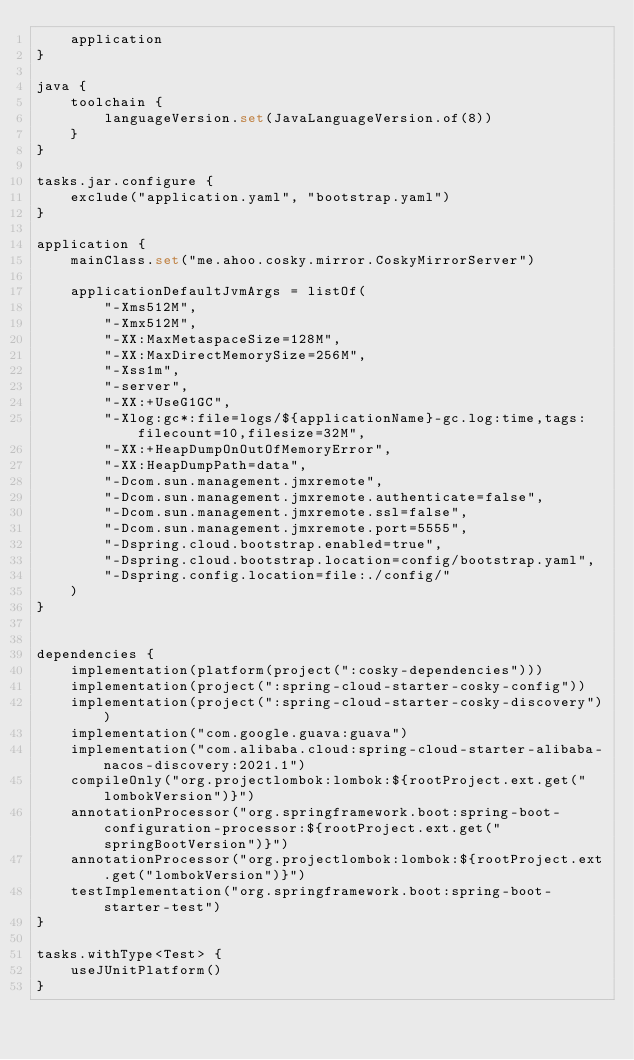<code> <loc_0><loc_0><loc_500><loc_500><_Kotlin_>    application
}

java {
    toolchain {
        languageVersion.set(JavaLanguageVersion.of(8))
    }
}

tasks.jar.configure {
    exclude("application.yaml", "bootstrap.yaml")
}

application {
    mainClass.set("me.ahoo.cosky.mirror.CoskyMirrorServer")

    applicationDefaultJvmArgs = listOf(
        "-Xms512M",
        "-Xmx512M",
        "-XX:MaxMetaspaceSize=128M",
        "-XX:MaxDirectMemorySize=256M",
        "-Xss1m",
        "-server",
        "-XX:+UseG1GC",
        "-Xlog:gc*:file=logs/${applicationName}-gc.log:time,tags:filecount=10,filesize=32M",
        "-XX:+HeapDumpOnOutOfMemoryError",
        "-XX:HeapDumpPath=data",
        "-Dcom.sun.management.jmxremote",
        "-Dcom.sun.management.jmxremote.authenticate=false",
        "-Dcom.sun.management.jmxremote.ssl=false",
        "-Dcom.sun.management.jmxremote.port=5555",
        "-Dspring.cloud.bootstrap.enabled=true",
        "-Dspring.cloud.bootstrap.location=config/bootstrap.yaml",
        "-Dspring.config.location=file:./config/"
    )
}


dependencies {
    implementation(platform(project(":cosky-dependencies")))
    implementation(project(":spring-cloud-starter-cosky-config"))
    implementation(project(":spring-cloud-starter-cosky-discovery"))
    implementation("com.google.guava:guava")
    implementation("com.alibaba.cloud:spring-cloud-starter-alibaba-nacos-discovery:2021.1")
    compileOnly("org.projectlombok:lombok:${rootProject.ext.get("lombokVersion")}")
    annotationProcessor("org.springframework.boot:spring-boot-configuration-processor:${rootProject.ext.get("springBootVersion")}")
    annotationProcessor("org.projectlombok:lombok:${rootProject.ext.get("lombokVersion")}")
    testImplementation("org.springframework.boot:spring-boot-starter-test")
}

tasks.withType<Test> {
    useJUnitPlatform()
}
</code> 